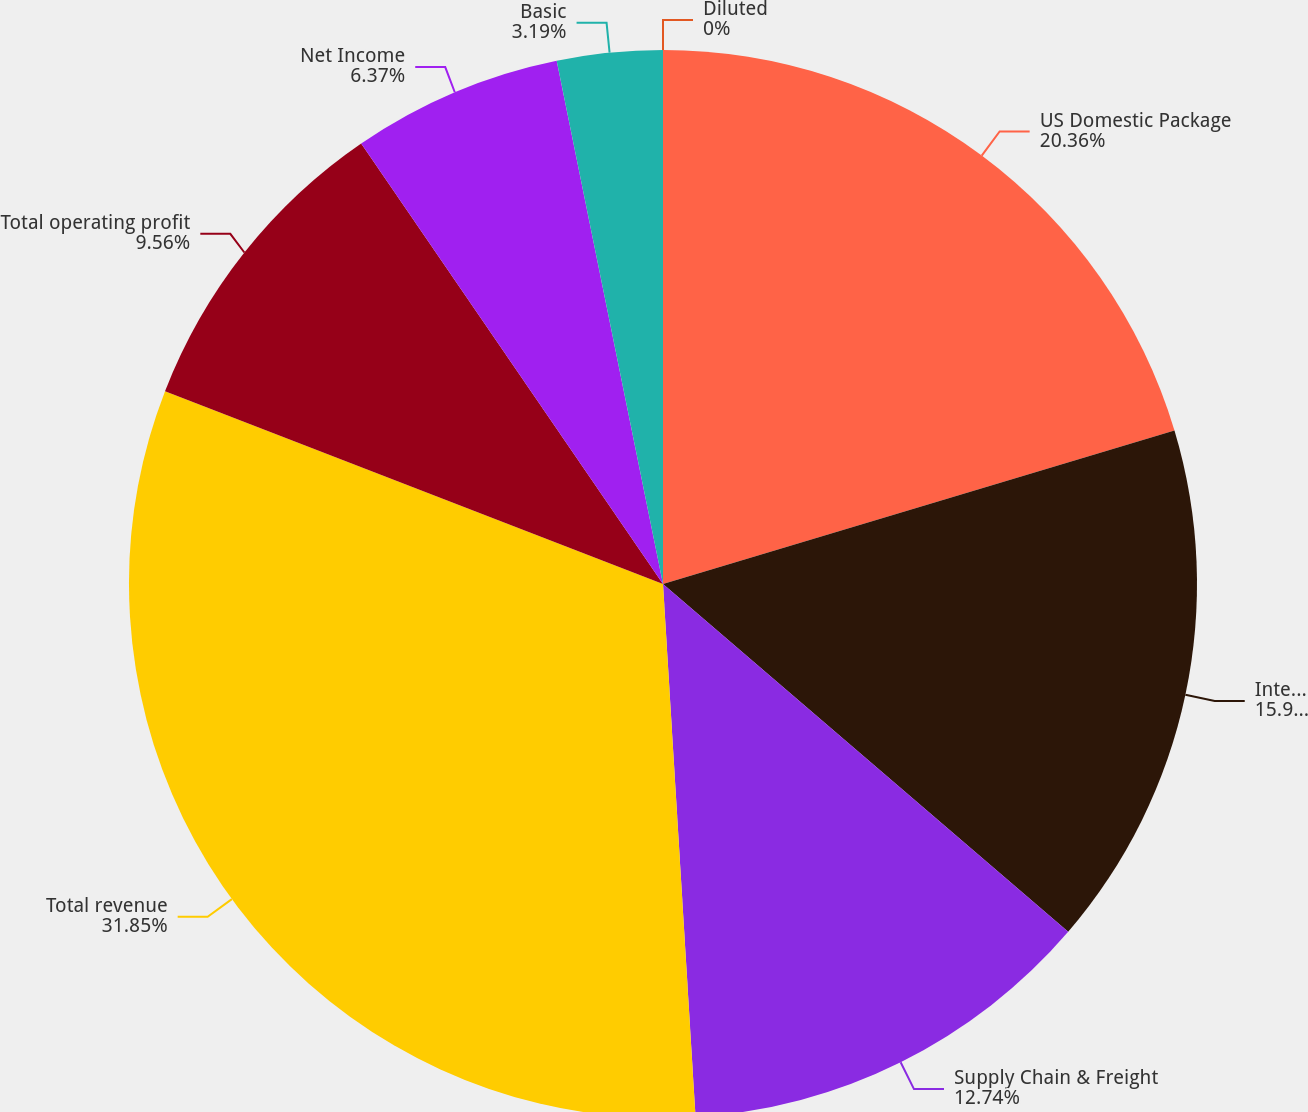Convert chart to OTSL. <chart><loc_0><loc_0><loc_500><loc_500><pie_chart><fcel>US Domestic Package<fcel>International Package<fcel>Supply Chain & Freight<fcel>Total revenue<fcel>Total operating profit<fcel>Net Income<fcel>Basic<fcel>Diluted<nl><fcel>20.36%<fcel>15.93%<fcel>12.74%<fcel>31.85%<fcel>9.56%<fcel>6.37%<fcel>3.19%<fcel>0.0%<nl></chart> 